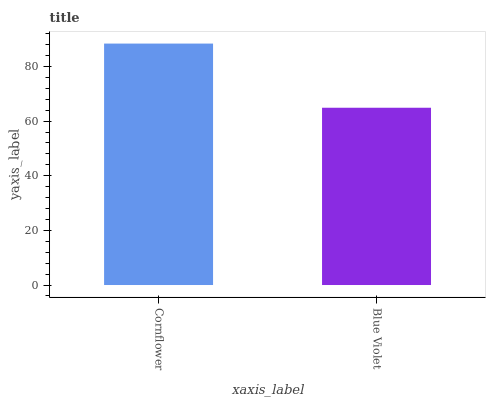Is Blue Violet the minimum?
Answer yes or no. Yes. Is Cornflower the maximum?
Answer yes or no. Yes. Is Blue Violet the maximum?
Answer yes or no. No. Is Cornflower greater than Blue Violet?
Answer yes or no. Yes. Is Blue Violet less than Cornflower?
Answer yes or no. Yes. Is Blue Violet greater than Cornflower?
Answer yes or no. No. Is Cornflower less than Blue Violet?
Answer yes or no. No. Is Cornflower the high median?
Answer yes or no. Yes. Is Blue Violet the low median?
Answer yes or no. Yes. Is Blue Violet the high median?
Answer yes or no. No. Is Cornflower the low median?
Answer yes or no. No. 